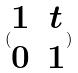Convert formula to latex. <formula><loc_0><loc_0><loc_500><loc_500>( \begin{matrix} 1 & t \\ 0 & 1 \end{matrix} )</formula> 